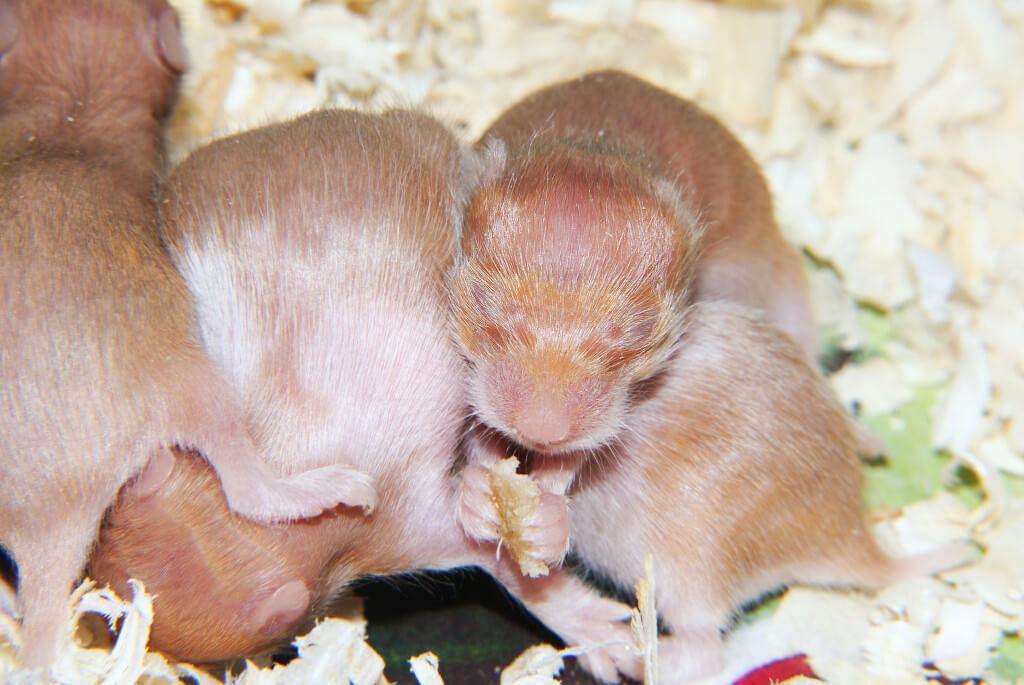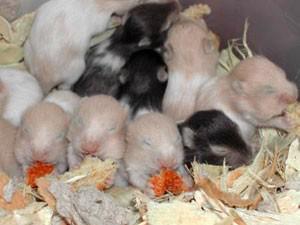The first image is the image on the left, the second image is the image on the right. Given the left and right images, does the statement "An image contains at least one blackish newborn rodent." hold true? Answer yes or no. Yes. The first image is the image on the left, the second image is the image on the right. Considering the images on both sides, is "At least one mouse has it's eyes wide open and and least one mouse is sleeping." valid? Answer yes or no. No. 